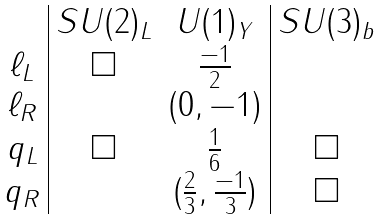Convert formula to latex. <formula><loc_0><loc_0><loc_500><loc_500>\begin{array} { c | c c | c } & S U ( 2 ) _ { L } & U ( 1 ) _ { Y } & S U ( 3 ) _ { b } \\ \ell _ { L } & \Box & \frac { - 1 } { 2 } & \\ \ell _ { R } & & ( 0 , - 1 ) & \\ q _ { L } & \Box & \frac { 1 } { 6 } & \Box \\ q _ { R } & & ( \frac { 2 } { 3 } , \frac { - 1 } { 3 } ) & \Box \end{array}</formula> 